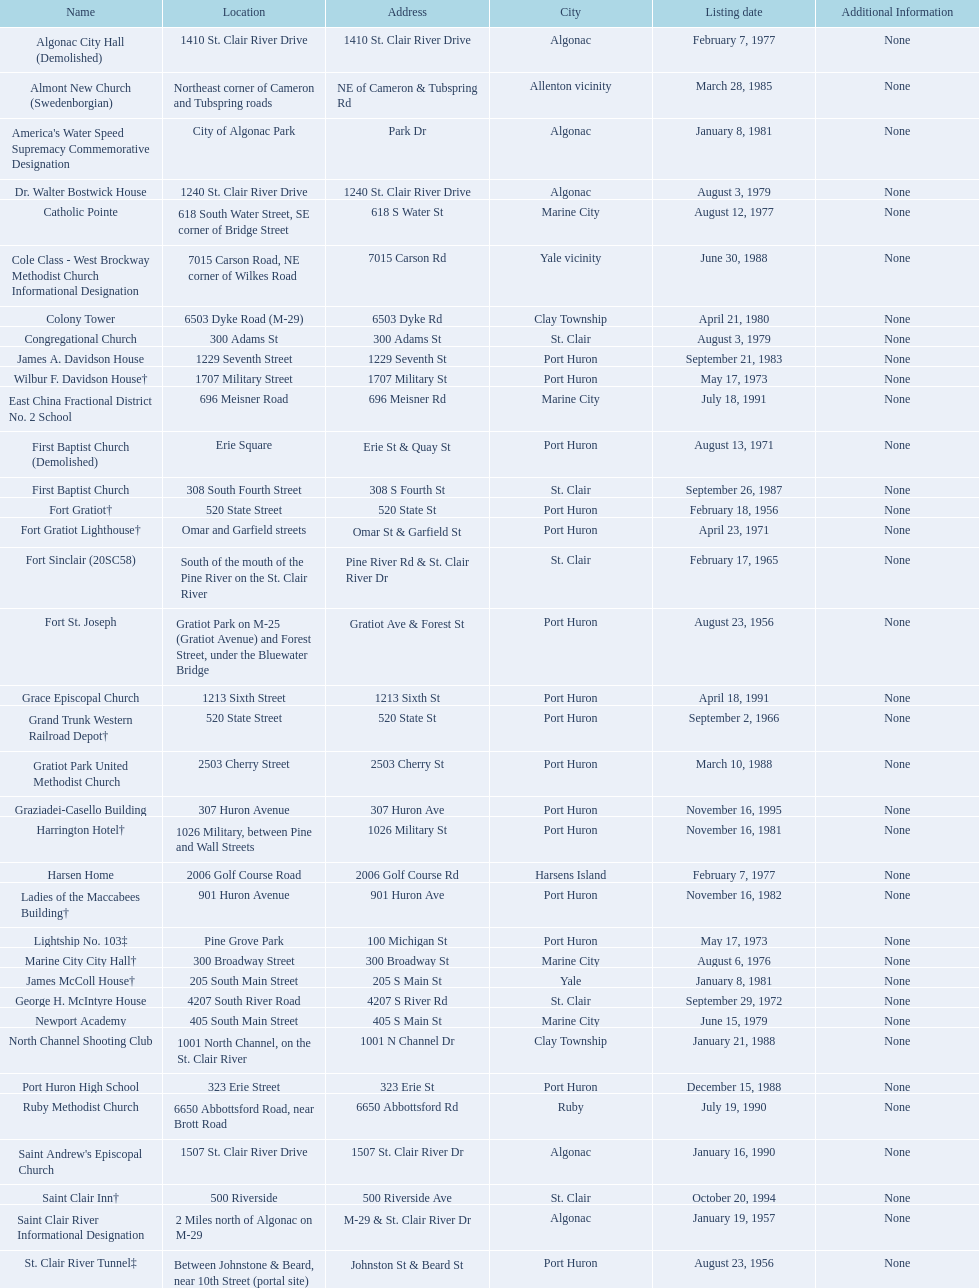Fort gratiot lighthouse and fort st. joseph are located in what city? Port Huron. 